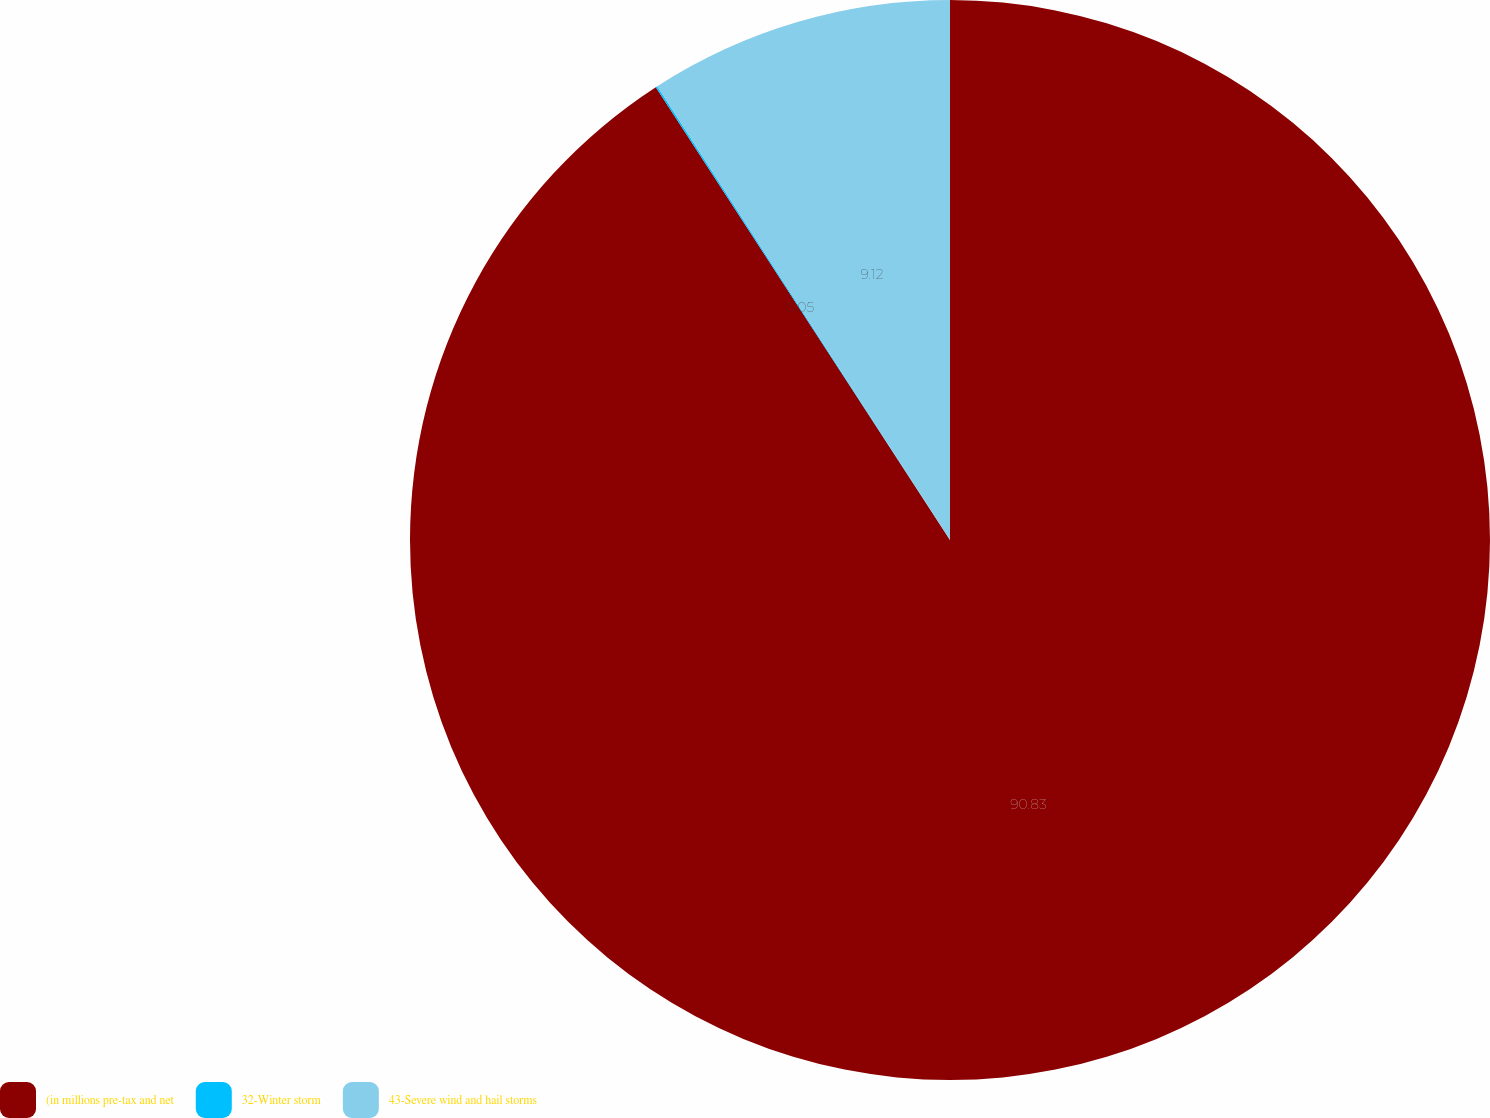<chart> <loc_0><loc_0><loc_500><loc_500><pie_chart><fcel>(in millions pre-tax and net<fcel>32-Winter storm<fcel>43-Severe wind and hail storms<nl><fcel>90.83%<fcel>0.05%<fcel>9.12%<nl></chart> 